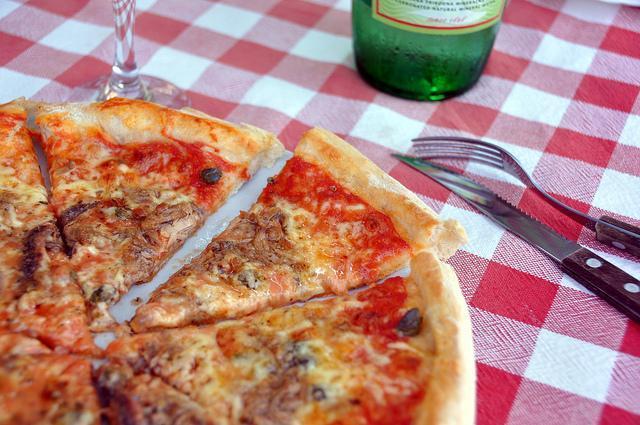How many pizzas are visible?
Give a very brief answer. 4. 